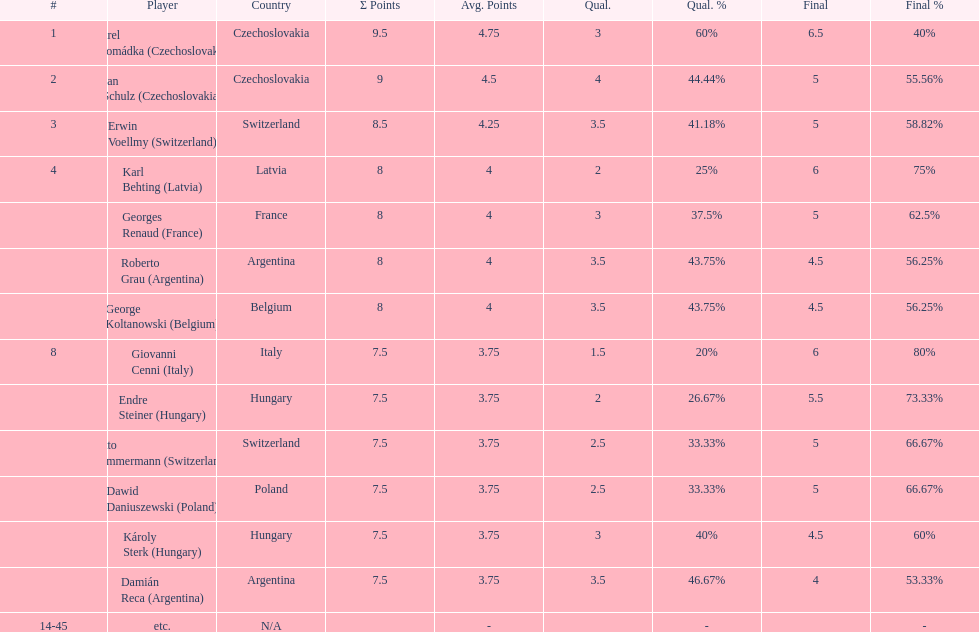Karl behting and giovanni cenni each had final scores of what? 6. 